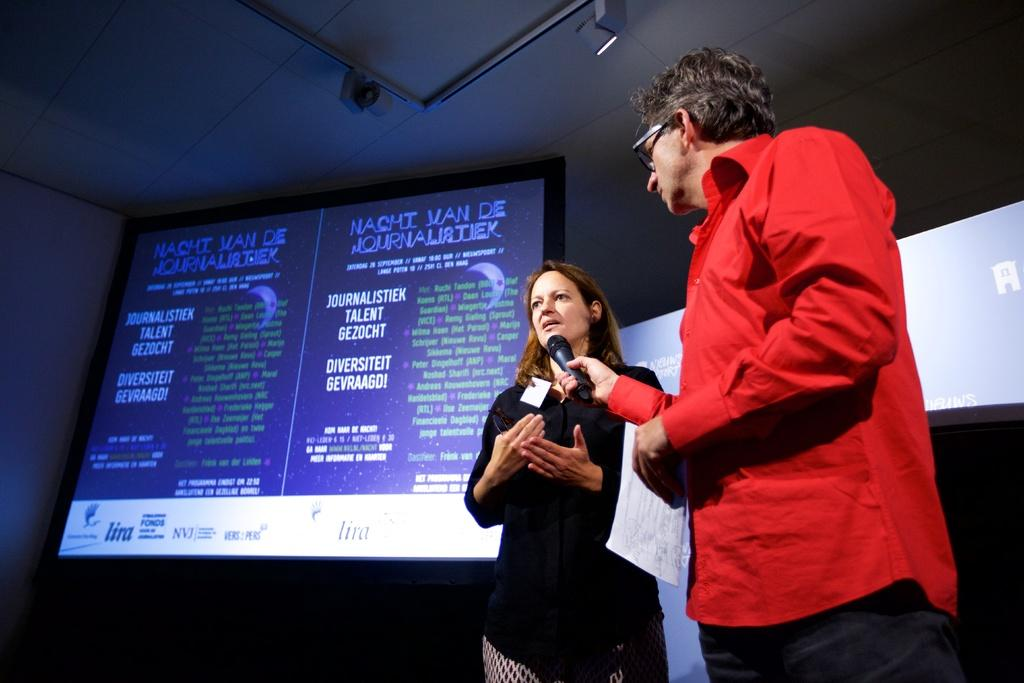How many people are present in the image? There is a man and a woman in the image, making a total of two people. What is the man holding in the image? The man is holding a microphone. What can be seen in the background of the image? There are screens, a wall, a roof, and other objects visible in the background of the image. What might the man and woman be doing in the image? They might be giving a presentation or speaking to an audience, given the presence of the microphone and screens. What type of harmony is the bee creating with the governor in the image? There is no bee or governor present in the image, so it is not possible to answer that question. 